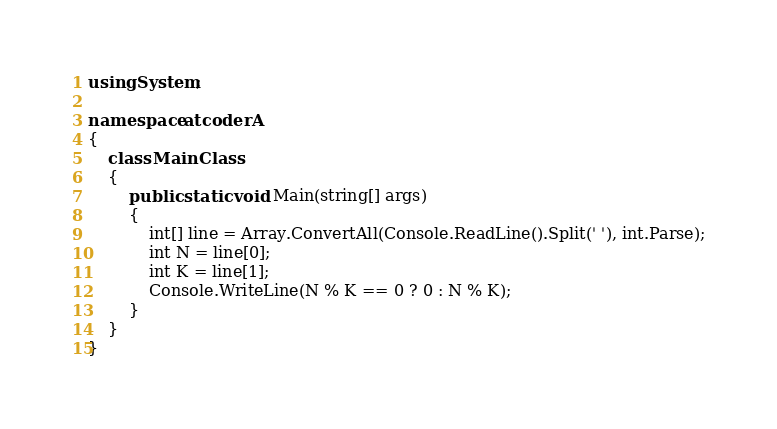Convert code to text. <code><loc_0><loc_0><loc_500><loc_500><_C#_>using System;

namespace atcoderA
{
    class MainClass
    {
        public static void Main(string[] args)
        {
            int[] line = Array.ConvertAll(Console.ReadLine().Split(' '), int.Parse);
            int N = line[0];
            int K = line[1];
            Console.WriteLine(N % K == 0 ? 0 : N % K);
        }
    }
}</code> 